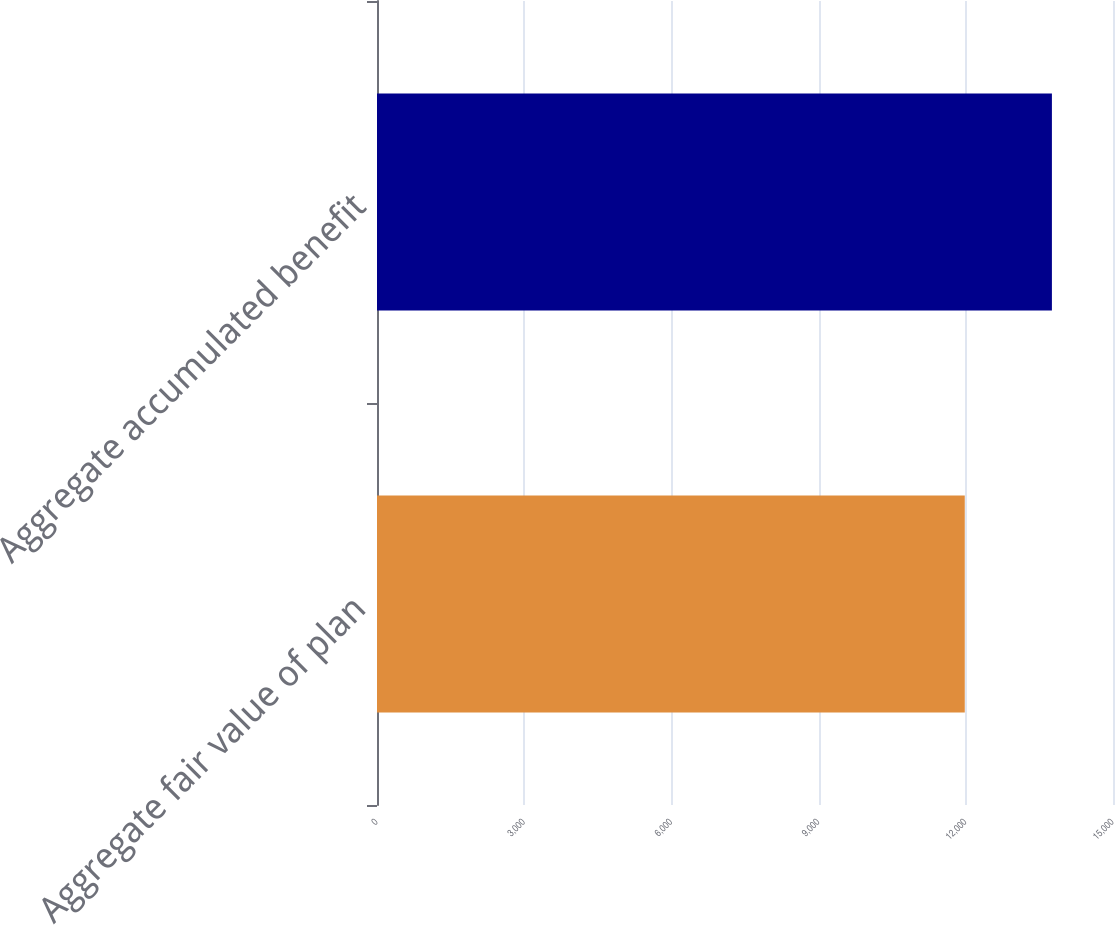Convert chart to OTSL. <chart><loc_0><loc_0><loc_500><loc_500><bar_chart><fcel>Aggregate fair value of plan<fcel>Aggregate accumulated benefit<nl><fcel>11979<fcel>13755<nl></chart> 